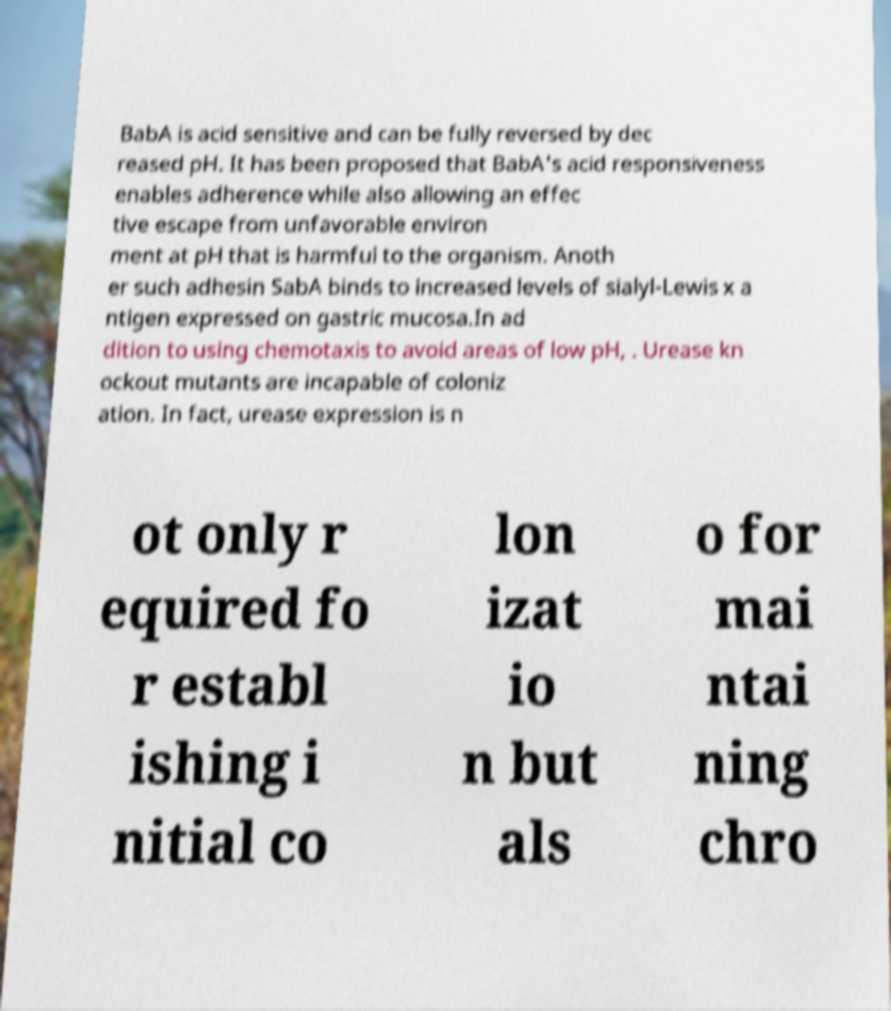Could you assist in decoding the text presented in this image and type it out clearly? BabA is acid sensitive and can be fully reversed by dec reased pH. It has been proposed that BabA's acid responsiveness enables adherence while also allowing an effec tive escape from unfavorable environ ment at pH that is harmful to the organism. Anoth er such adhesin SabA binds to increased levels of sialyl-Lewis x a ntigen expressed on gastric mucosa.In ad dition to using chemotaxis to avoid areas of low pH, . Urease kn ockout mutants are incapable of coloniz ation. In fact, urease expression is n ot only r equired fo r establ ishing i nitial co lon izat io n but als o for mai ntai ning chro 